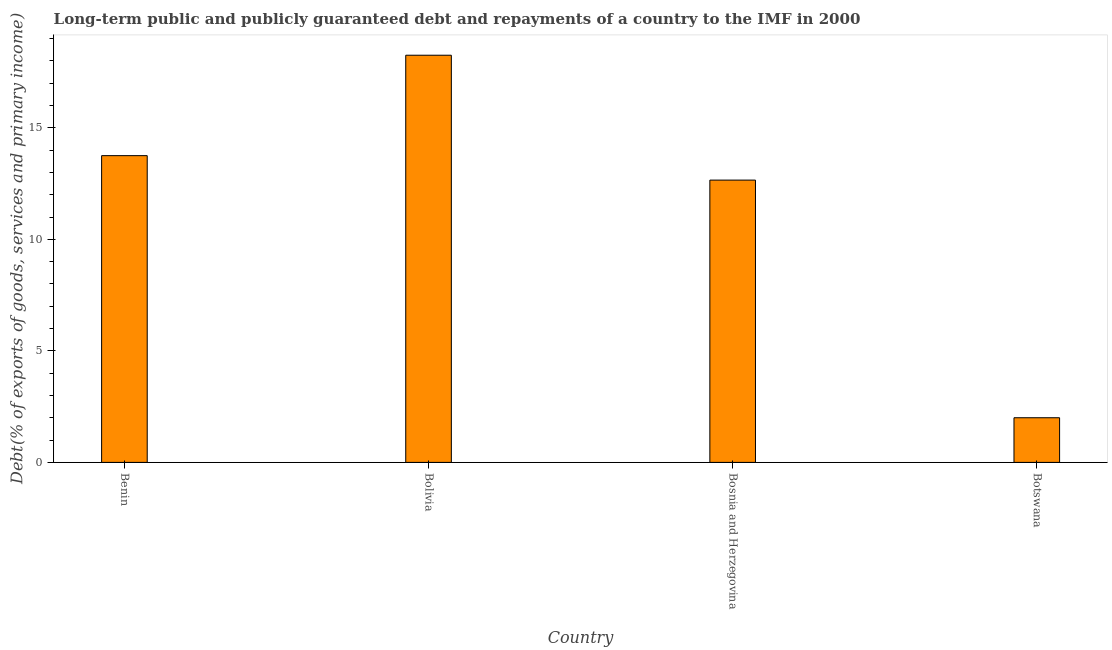Does the graph contain any zero values?
Your answer should be very brief. No. What is the title of the graph?
Provide a succinct answer. Long-term public and publicly guaranteed debt and repayments of a country to the IMF in 2000. What is the label or title of the X-axis?
Your response must be concise. Country. What is the label or title of the Y-axis?
Provide a short and direct response. Debt(% of exports of goods, services and primary income). What is the debt service in Bolivia?
Give a very brief answer. 18.25. Across all countries, what is the maximum debt service?
Ensure brevity in your answer.  18.25. Across all countries, what is the minimum debt service?
Offer a terse response. 2. In which country was the debt service maximum?
Your response must be concise. Bolivia. In which country was the debt service minimum?
Your response must be concise. Botswana. What is the sum of the debt service?
Your answer should be very brief. 46.66. What is the difference between the debt service in Bolivia and Bosnia and Herzegovina?
Make the answer very short. 5.6. What is the average debt service per country?
Your answer should be very brief. 11.66. What is the median debt service?
Your answer should be compact. 13.2. In how many countries, is the debt service greater than 12 %?
Provide a short and direct response. 3. What is the ratio of the debt service in Bolivia to that in Botswana?
Make the answer very short. 9.12. What is the difference between the highest and the second highest debt service?
Ensure brevity in your answer.  4.5. Is the sum of the debt service in Benin and Bolivia greater than the maximum debt service across all countries?
Provide a short and direct response. Yes. What is the difference between the highest and the lowest debt service?
Make the answer very short. 16.25. How many bars are there?
Your answer should be compact. 4. Are all the bars in the graph horizontal?
Provide a succinct answer. No. How many countries are there in the graph?
Your response must be concise. 4. What is the difference between two consecutive major ticks on the Y-axis?
Offer a terse response. 5. What is the Debt(% of exports of goods, services and primary income) of Benin?
Your answer should be very brief. 13.75. What is the Debt(% of exports of goods, services and primary income) in Bolivia?
Ensure brevity in your answer.  18.25. What is the Debt(% of exports of goods, services and primary income) in Bosnia and Herzegovina?
Keep it short and to the point. 12.65. What is the Debt(% of exports of goods, services and primary income) in Botswana?
Offer a terse response. 2. What is the difference between the Debt(% of exports of goods, services and primary income) in Benin and Bolivia?
Keep it short and to the point. -4.5. What is the difference between the Debt(% of exports of goods, services and primary income) in Benin and Bosnia and Herzegovina?
Make the answer very short. 1.1. What is the difference between the Debt(% of exports of goods, services and primary income) in Benin and Botswana?
Provide a short and direct response. 11.75. What is the difference between the Debt(% of exports of goods, services and primary income) in Bolivia and Bosnia and Herzegovina?
Make the answer very short. 5.6. What is the difference between the Debt(% of exports of goods, services and primary income) in Bolivia and Botswana?
Your response must be concise. 16.25. What is the difference between the Debt(% of exports of goods, services and primary income) in Bosnia and Herzegovina and Botswana?
Your response must be concise. 10.65. What is the ratio of the Debt(% of exports of goods, services and primary income) in Benin to that in Bolivia?
Offer a very short reply. 0.75. What is the ratio of the Debt(% of exports of goods, services and primary income) in Benin to that in Bosnia and Herzegovina?
Make the answer very short. 1.09. What is the ratio of the Debt(% of exports of goods, services and primary income) in Benin to that in Botswana?
Provide a succinct answer. 6.87. What is the ratio of the Debt(% of exports of goods, services and primary income) in Bolivia to that in Bosnia and Herzegovina?
Your response must be concise. 1.44. What is the ratio of the Debt(% of exports of goods, services and primary income) in Bolivia to that in Botswana?
Keep it short and to the point. 9.12. What is the ratio of the Debt(% of exports of goods, services and primary income) in Bosnia and Herzegovina to that in Botswana?
Offer a very short reply. 6.32. 